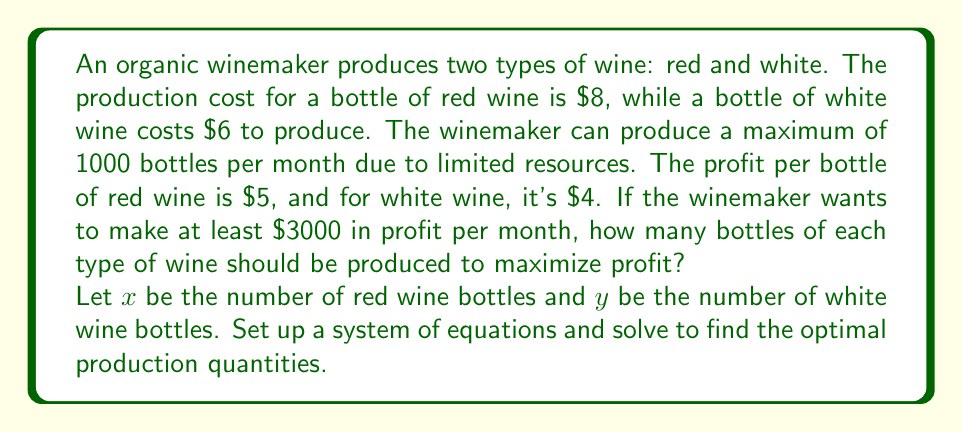Can you solve this math problem? Let's approach this step-by-step:

1) First, we need to set up our constraints:

   a) Total production constraint: $x + y \leq 1000$
   b) Profit constraint: $5x + 4y \geq 3000$
   c) Non-negativity constraints: $x \geq 0$, $y \geq 0$

2) Our objective function (profit) is: $P = 5x + 4y$

3) We can visualize this as a linear programming problem. The feasible region is bounded by the constraints.

4) The optimal solution will be at one of the corner points of the feasible region. These points are where the constraint lines intersect.

5) Let's find these intersection points:

   a) Between total production and profit constraints:
      $x + y = 1000$ and $5x + 4y = 3000$
      Solving this system:
      $4x + 4y = 4000$
      $5x + 4y = 3000$
      Subtracting, we get: $-x = -1000$, so $x = 1000$, $y = 0$

   b) Between x-axis and profit constraint:
      $y = 0$ and $5x = 3000$
      $x = 600$, $y = 0$

   c) Between y-axis and profit constraint:
      $x = 0$ and $4y = 3000$
      $x = 0$, $y = 750$

6) Now, let's evaluate the profit at each of these points:
   (1000, 0): $P = 5(1000) + 4(0) = 5000$
   (600, 0): $P = 5(600) + 4(0) = 3000$
   (0, 750): $P = 5(0) + 4(750) = 3000$

7) The maximum profit is achieved at the point (1000, 0), which means producing 1000 bottles of red wine and 0 bottles of white wine.
Answer: 1000 bottles of red wine, 0 bottles of white wine 